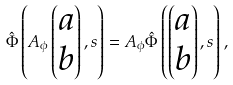<formula> <loc_0><loc_0><loc_500><loc_500>\hat { \Phi } \left ( A _ { \phi } \begin{pmatrix} a \\ b \end{pmatrix} , s \right ) = A _ { \phi } \hat { \Phi } \left ( \begin{pmatrix} a \\ b \end{pmatrix} , s \right ) ,</formula> 